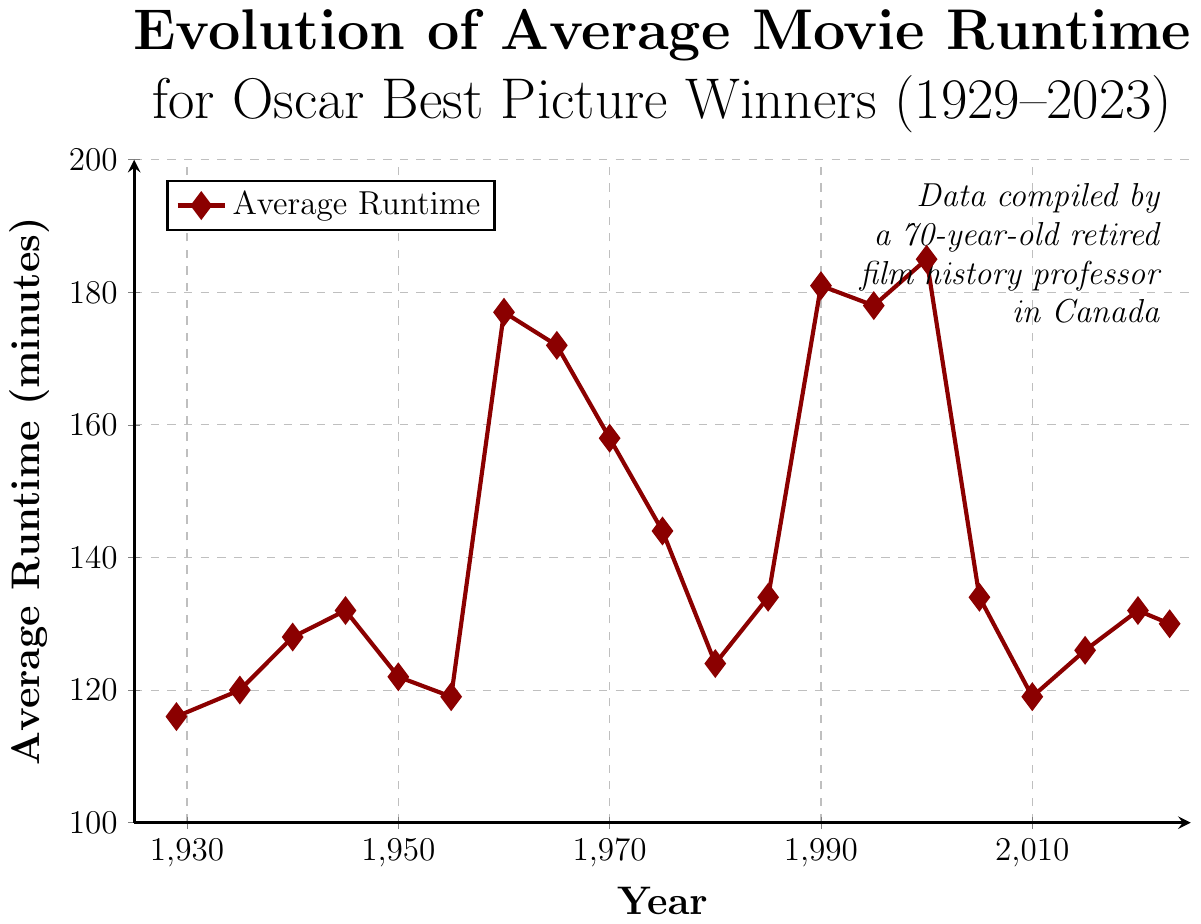What is the average movie runtime for Oscar Best Picture winners in 1929? The figure shows the point corresponding to the year 1929 and reads 116 minutes.
Answer: 116 minutes Between which years did the average runtime see the most significant jump? The figure shows a large jump between 1955 (119 minutes) to 1960 (177 minutes). The difference here is the greatest.
Answer: 1955 to 1960 How does the average runtime in 2000 compare to that in 2023? In 2000, the point is at 185 minutes, and in 2023, it is at 130 minutes. The point in 2000 is higher than in 2023.
Answer: 2000 is higher What is the highest average runtime shown in the figure, and in which year did it occur? The figure shows the highest point at 2000 with an average runtime of 185 minutes.
Answer: 185 minutes in the year 2000 In which decade did the average runtime first exceed 140 minutes? By examining the graph, the average runtime first exceeds 140 minutes in the 1960s, particularly in 1960 (177 minutes).
Answer: 1960s What is the difference in average runtime between the years 1945 and 1955? The figure shows 132 minutes for 1945 and 119 minutes for 1955. The difference is calculated as 132 - 119 = 13 minutes.
Answer: 13 minutes By how many minutes did the average runtime decrease from 1995 to 2005? The figure shows 178 minutes for 1995 and 134 minutes for 2005. The decrease is calculated as 178 - 134 = 44 minutes.
Answer: 44 minutes What is the color and shape of the markers used in the plot? The plot uses diamond-shaped markers with a dark red color.
Answer: Dark red, diamond-shaped How many years in the figure show an average runtime below 130 minutes? By visually inspecting the graph, the years with runtime below 130 minutes are 1929, 1935, 1955, 1975, 1980, 2005, and 2010—that's 7 years.
Answer: 7 years 